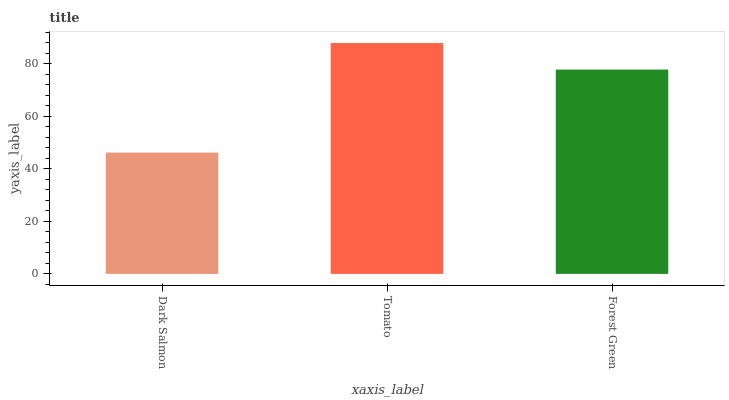Is Dark Salmon the minimum?
Answer yes or no. Yes. Is Tomato the maximum?
Answer yes or no. Yes. Is Forest Green the minimum?
Answer yes or no. No. Is Forest Green the maximum?
Answer yes or no. No. Is Tomato greater than Forest Green?
Answer yes or no. Yes. Is Forest Green less than Tomato?
Answer yes or no. Yes. Is Forest Green greater than Tomato?
Answer yes or no. No. Is Tomato less than Forest Green?
Answer yes or no. No. Is Forest Green the high median?
Answer yes or no. Yes. Is Forest Green the low median?
Answer yes or no. Yes. Is Tomato the high median?
Answer yes or no. No. Is Tomato the low median?
Answer yes or no. No. 